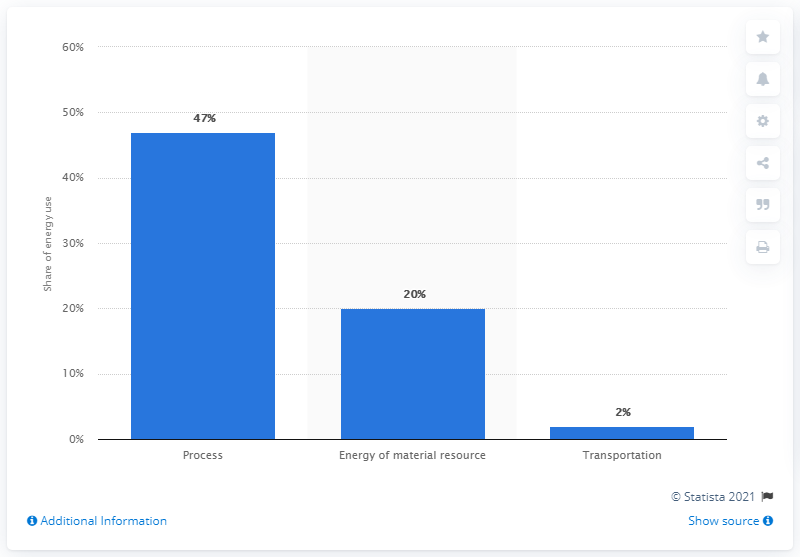Draw attention to some important aspects in this diagram. In 2003, the process segment consumed approximately 47% of the total energy used in the company. 